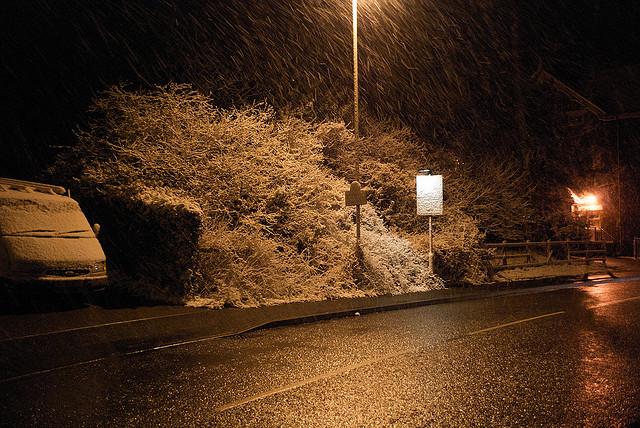What is dangerous about driving here now?
Write a very short answer. Wet road. Is it raining or snowing?
Write a very short answer. Snowing. Is it daytime or nighttime?
Short answer required. Nighttime. 